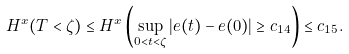<formula> <loc_0><loc_0><loc_500><loc_500>H ^ { x } ( T < \zeta ) \leq H ^ { x } \left ( \sup _ { 0 < t < \zeta } | e ( t ) - e ( 0 ) | \geq c _ { 1 4 } \right ) \leq c _ { 1 5 } .</formula> 